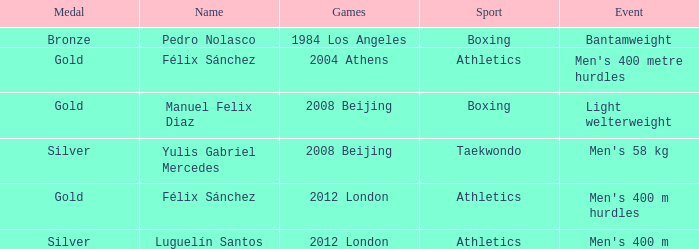Which name was associated with the 2008 beijing games and a gold medal? Manuel Felix Diaz. 